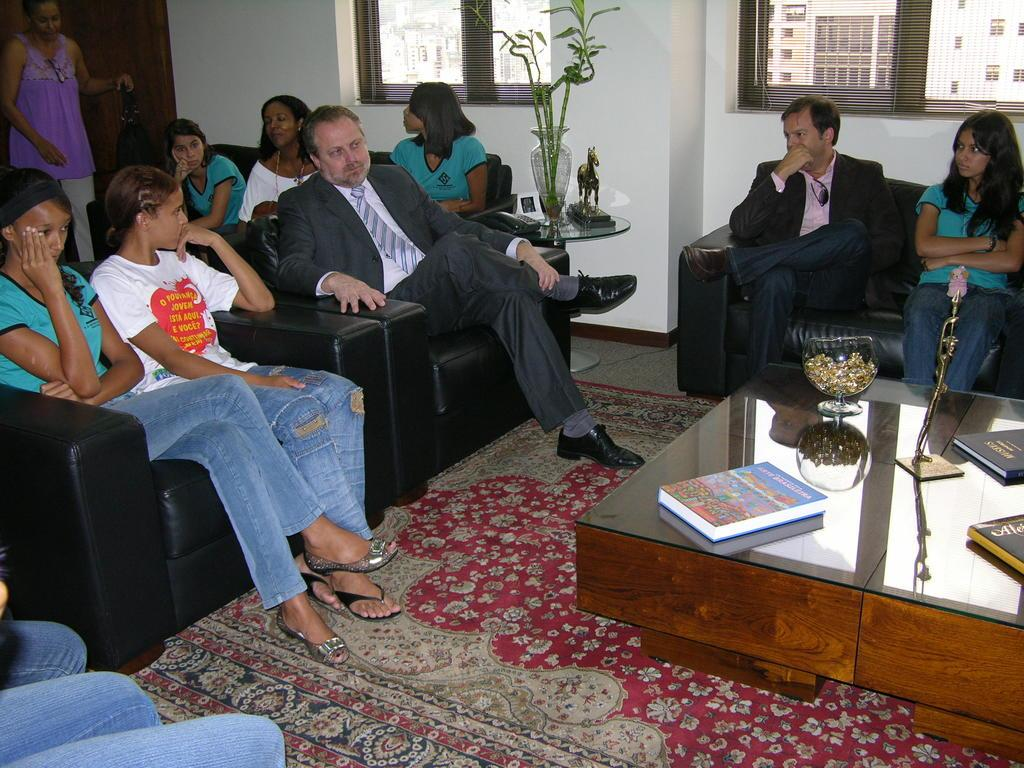Who is present in the image? There are people in the image. What are the people doing in the image? The people are sitting in sofas. Can you describe the setting of the image? The setting is a waiting room. What type of joke can be seen being told in the image? There is no joke being told in the image; the people are simply sitting in sofas in a waiting room. 